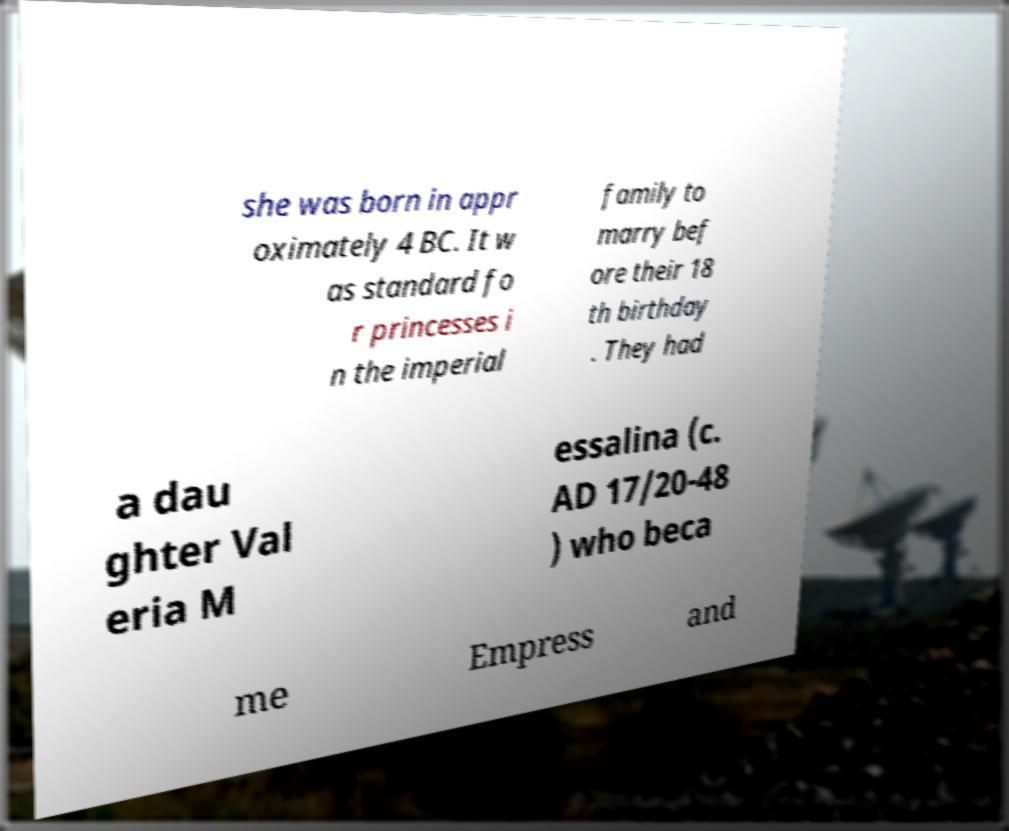I need the written content from this picture converted into text. Can you do that? she was born in appr oximately 4 BC. It w as standard fo r princesses i n the imperial family to marry bef ore their 18 th birthday . They had a dau ghter Val eria M essalina (c. AD 17/20-48 ) who beca me Empress and 